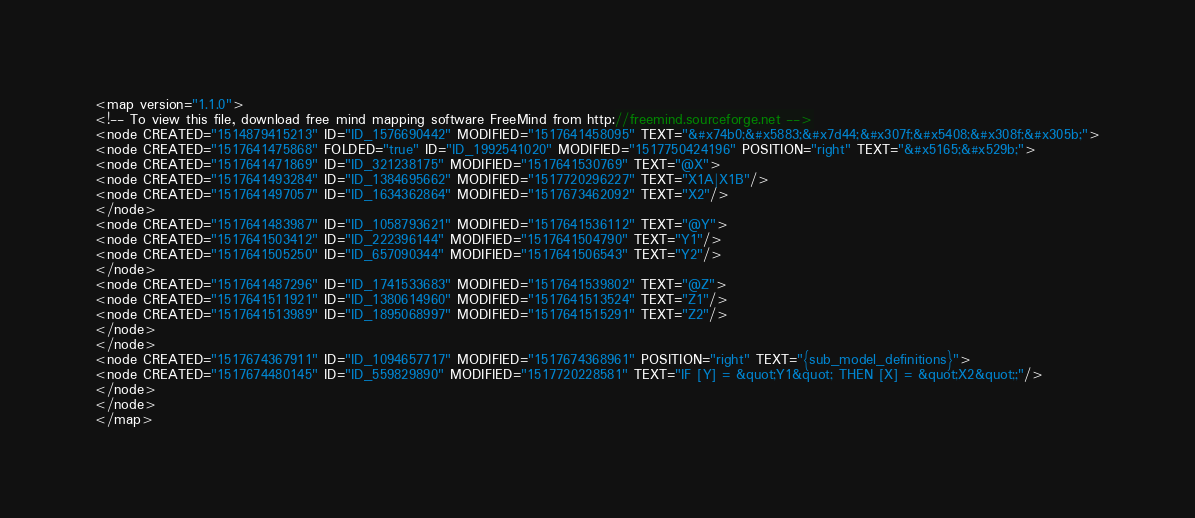Convert code to text. <code><loc_0><loc_0><loc_500><loc_500><_ObjectiveC_><map version="1.1.0">
<!-- To view this file, download free mind mapping software FreeMind from http://freemind.sourceforge.net -->
<node CREATED="1514879415213" ID="ID_1576690442" MODIFIED="1517641458095" TEXT="&#x74b0;&#x5883;&#x7d44;&#x307f;&#x5408;&#x308f;&#x305b;">
<node CREATED="1517641475868" FOLDED="true" ID="ID_1992541020" MODIFIED="1517750424196" POSITION="right" TEXT="&#x5165;&#x529b;">
<node CREATED="1517641471869" ID="ID_321238175" MODIFIED="1517641530769" TEXT="@X">
<node CREATED="1517641493284" ID="ID_1384695662" MODIFIED="1517720296227" TEXT="X1A|X1B"/>
<node CREATED="1517641497057" ID="ID_1634362864" MODIFIED="1517673462092" TEXT="X2"/>
</node>
<node CREATED="1517641483987" ID="ID_1058793621" MODIFIED="1517641536112" TEXT="@Y">
<node CREATED="1517641503412" ID="ID_222396144" MODIFIED="1517641504790" TEXT="Y1"/>
<node CREATED="1517641505250" ID="ID_657090344" MODIFIED="1517641506543" TEXT="Y2"/>
</node>
<node CREATED="1517641487296" ID="ID_1741533683" MODIFIED="1517641539802" TEXT="@Z">
<node CREATED="1517641511921" ID="ID_1380614960" MODIFIED="1517641513524" TEXT="Z1"/>
<node CREATED="1517641513989" ID="ID_1895068997" MODIFIED="1517641515291" TEXT="Z2"/>
</node>
</node>
<node CREATED="1517674367911" ID="ID_1094657717" MODIFIED="1517674368961" POSITION="right" TEXT="{sub_model_definitions}">
<node CREATED="1517674480145" ID="ID_559829890" MODIFIED="1517720228581" TEXT="IF [Y] = &quot;Y1&quot; THEN [X] = &quot;X2&quot;;"/>
</node>
</node>
</map>
</code> 